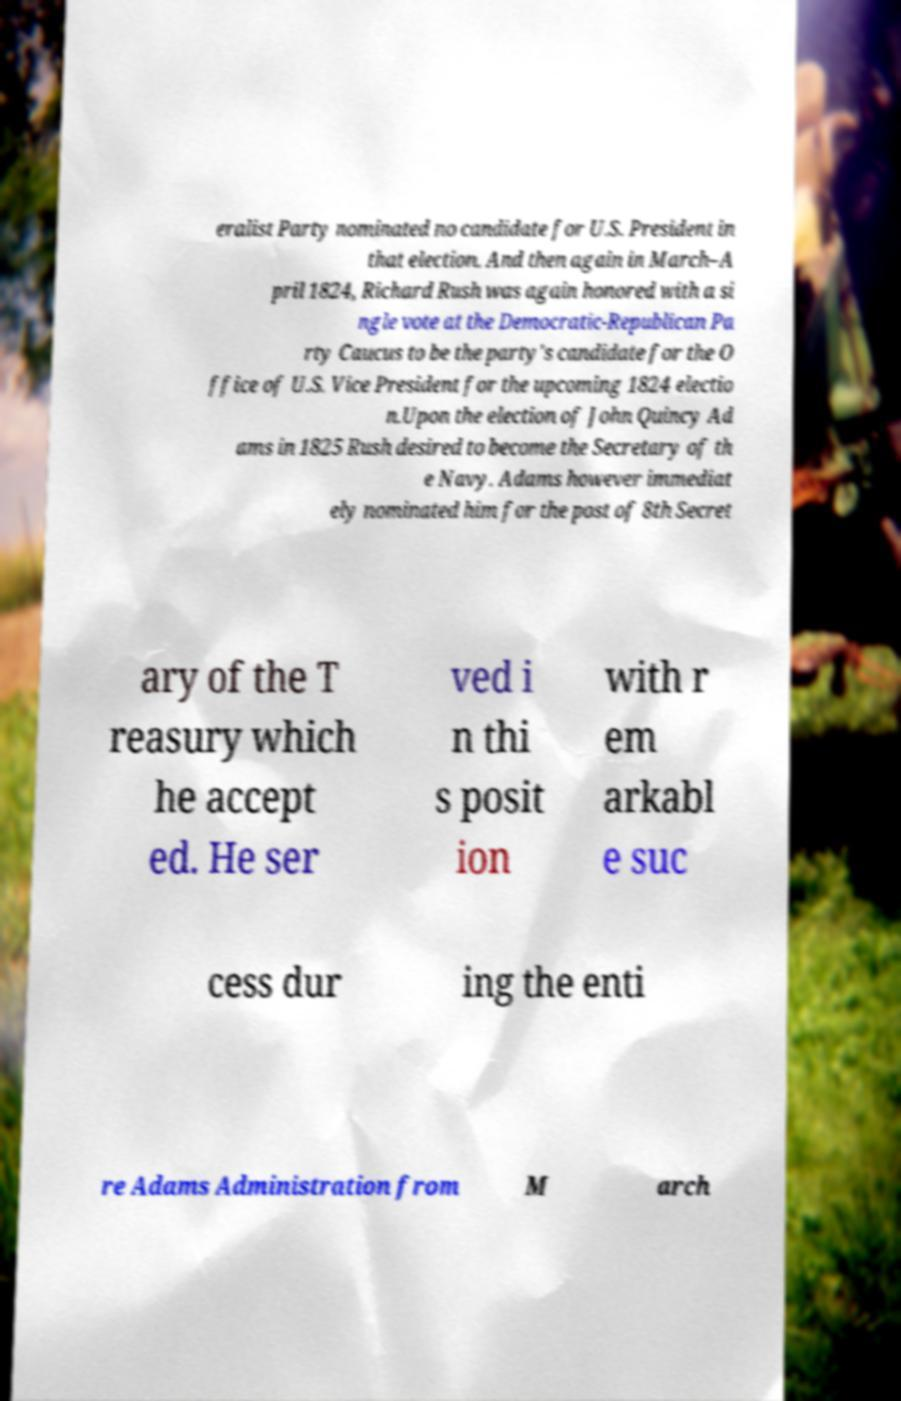Please identify and transcribe the text found in this image. eralist Party nominated no candidate for U.S. President in that election. And then again in March–A pril 1824, Richard Rush was again honored with a si ngle vote at the Democratic-Republican Pa rty Caucus to be the party's candidate for the O ffice of U.S. Vice President for the upcoming 1824 electio n.Upon the election of John Quincy Ad ams in 1825 Rush desired to become the Secretary of th e Navy. Adams however immediat ely nominated him for the post of 8th Secret ary of the T reasury which he accept ed. He ser ved i n thi s posit ion with r em arkabl e suc cess dur ing the enti re Adams Administration from M arch 